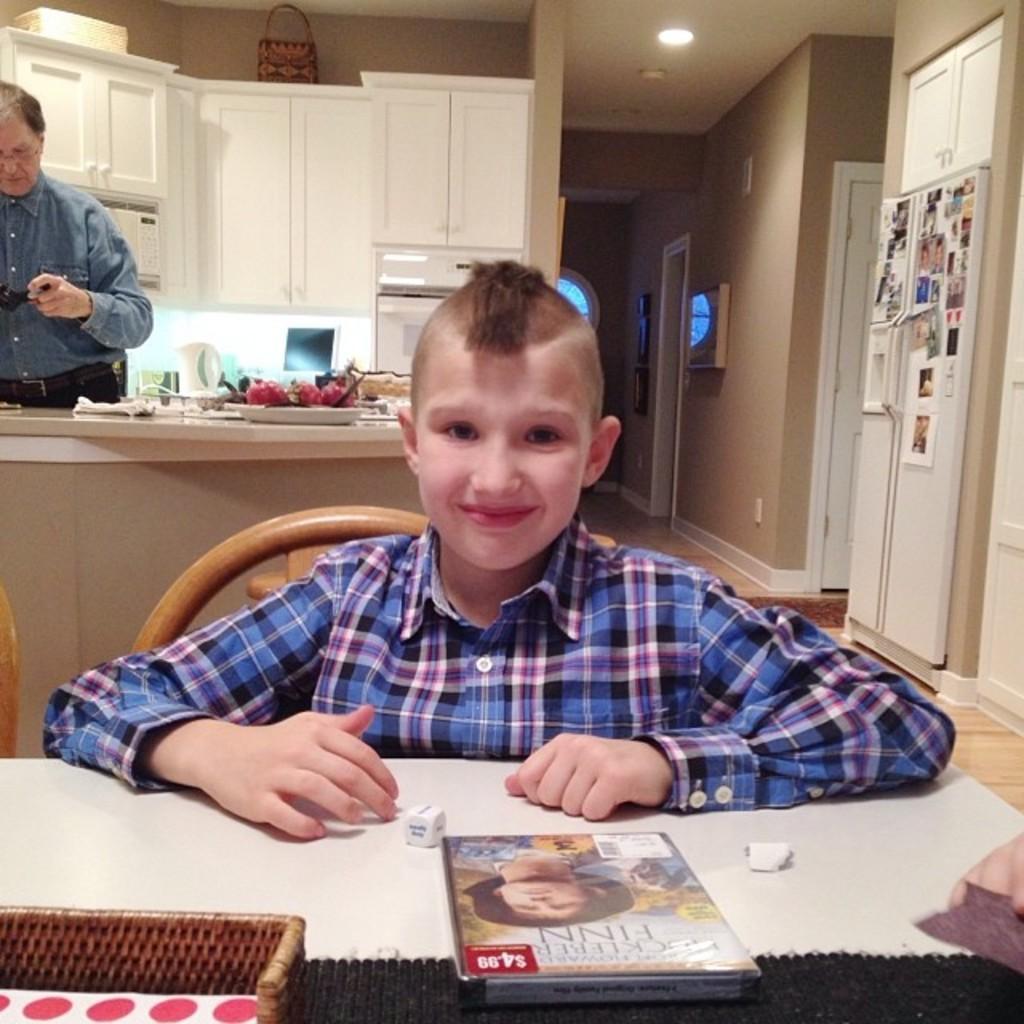Please provide a concise description of this image. On the background of the picture we can see a wall and a cupboard in white colour. This is ceiling and it's a light. Here we can see few photo frames on the cupboard. Here we can see one person standing in front of a platform. Infront of the picture we can see a boy sitting on a chair in front of a table where i can see a magazine. this boy is holding a smile on his face. 